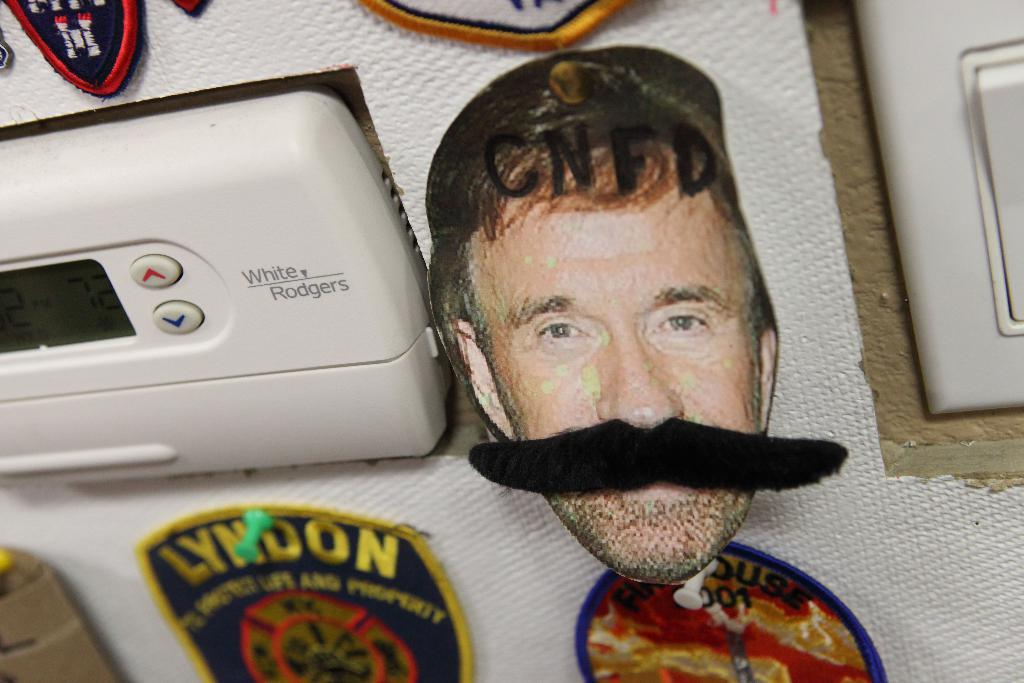<image>
Offer a succinct explanation of the picture presented. a patch that says 'lyndon' in yellow on it 